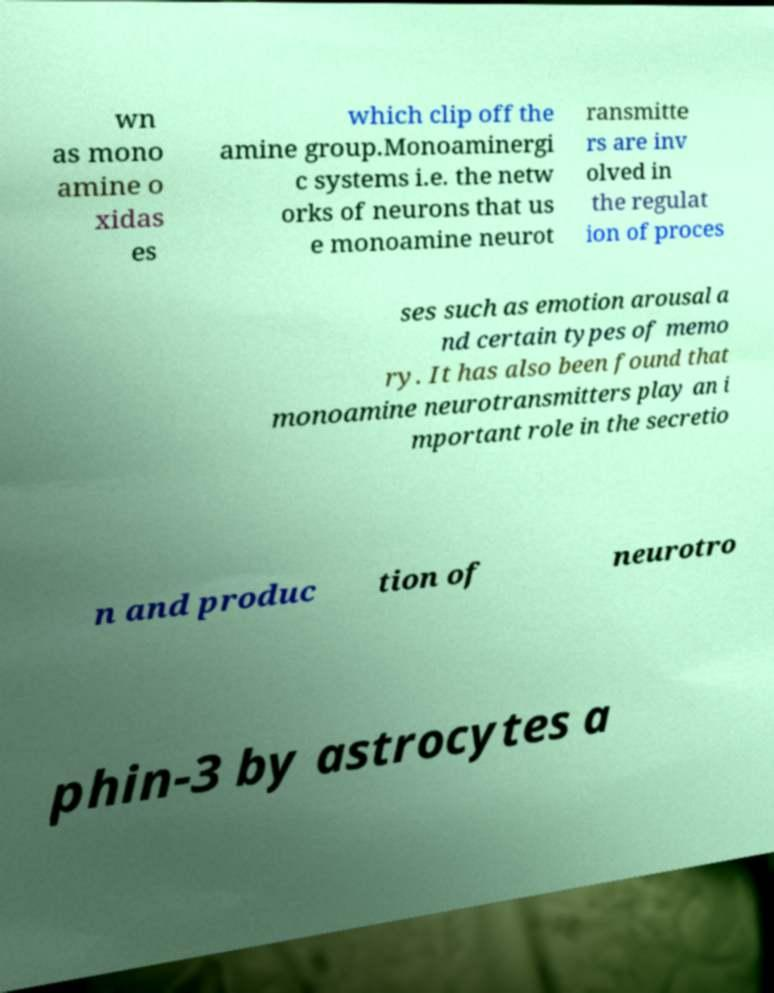Can you accurately transcribe the text from the provided image for me? wn as mono amine o xidas es which clip off the amine group.Monoaminergi c systems i.e. the netw orks of neurons that us e monoamine neurot ransmitte rs are inv olved in the regulat ion of proces ses such as emotion arousal a nd certain types of memo ry. It has also been found that monoamine neurotransmitters play an i mportant role in the secretio n and produc tion of neurotro phin-3 by astrocytes a 